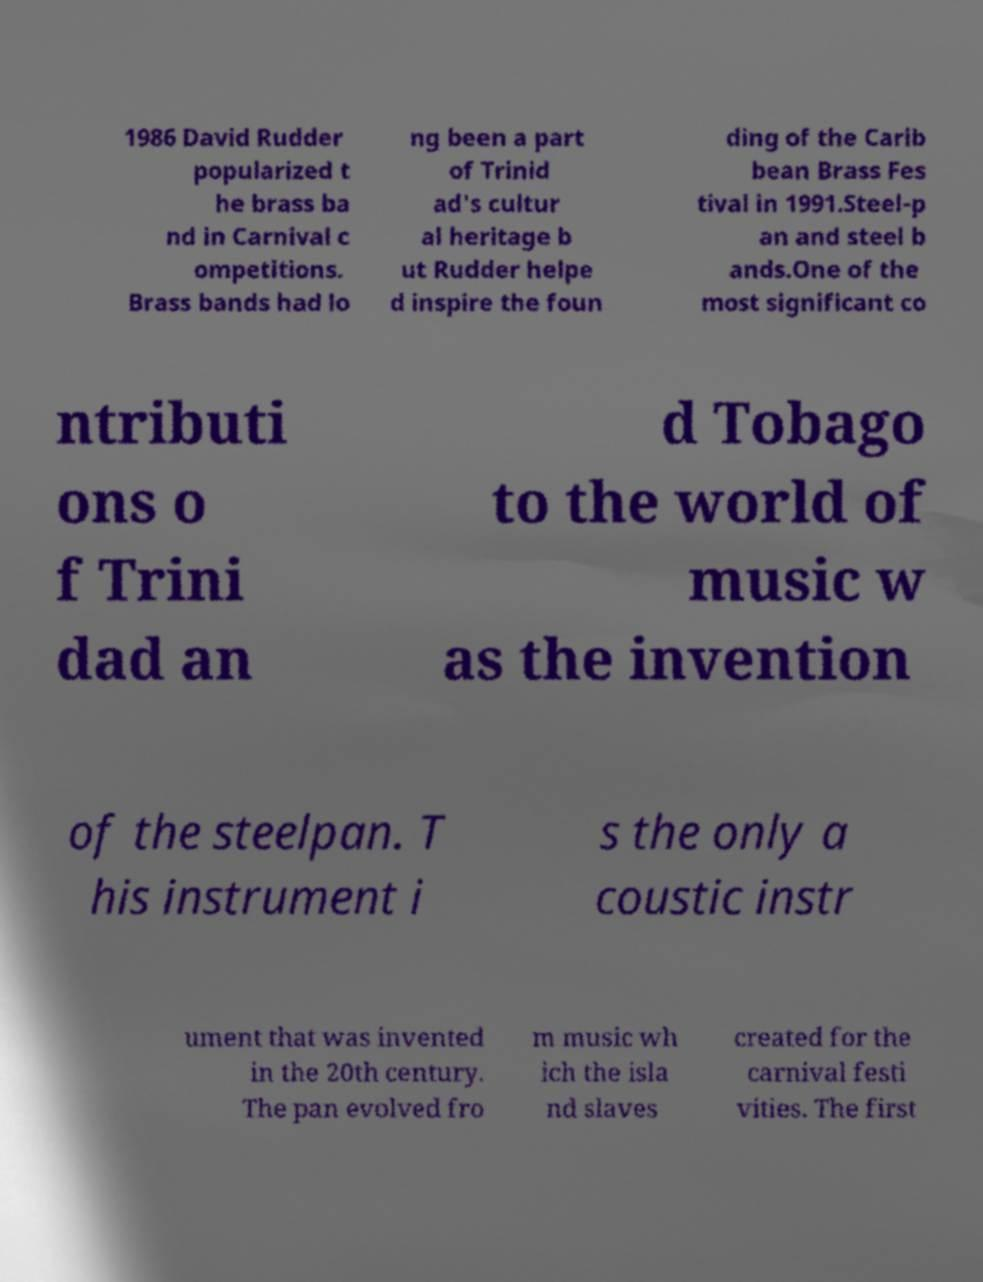Please identify and transcribe the text found in this image. 1986 David Rudder popularized t he brass ba nd in Carnival c ompetitions. Brass bands had lo ng been a part of Trinid ad's cultur al heritage b ut Rudder helpe d inspire the foun ding of the Carib bean Brass Fes tival in 1991.Steel-p an and steel b ands.One of the most significant co ntributi ons o f Trini dad an d Tobago to the world of music w as the invention of the steelpan. T his instrument i s the only a coustic instr ument that was invented in the 20th century. The pan evolved fro m music wh ich the isla nd slaves created for the carnival festi vities. The first 